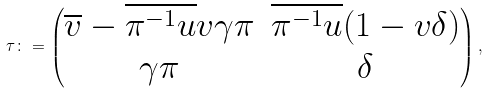Convert formula to latex. <formula><loc_0><loc_0><loc_500><loc_500>\tau \colon = \begin{pmatrix} \overline { v } - \overline { \pi ^ { - 1 } u } v \gamma \pi & \overline { \pi ^ { - 1 } u } ( 1 - v \delta ) \\ \gamma \pi & \delta \end{pmatrix} ,</formula> 